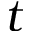Convert formula to latex. <formula><loc_0><loc_0><loc_500><loc_500>t</formula> 